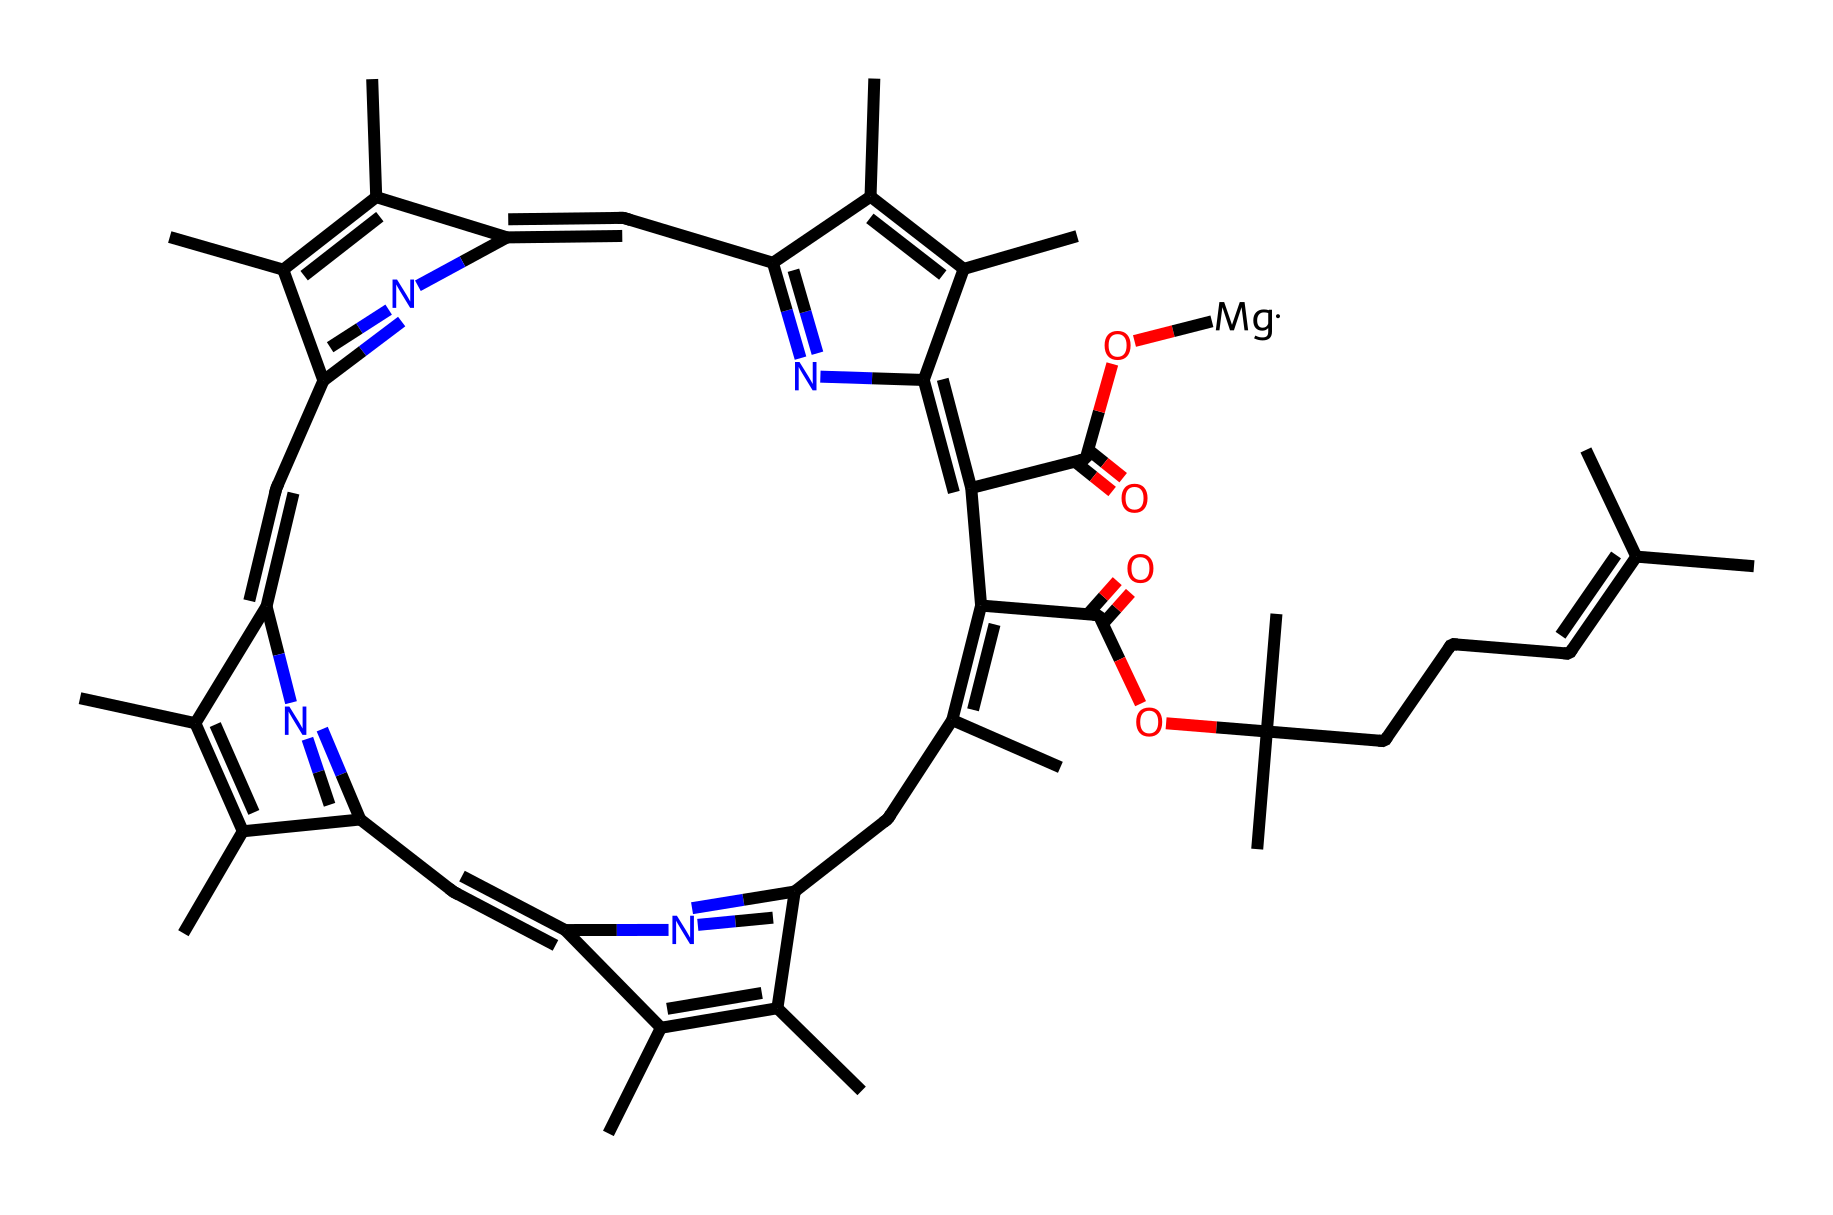What is the central metal atom in the chlorophyll structure? The SMILES representation indicates the presence of a magnesium atom, which is typically located at the center of the chlorophyll molecule, coordinating with the surrounding nitrogen and carbon atoms in the structure.
Answer: magnesium How many nitrogen atoms are present in chlorophyll? In the given SMILES representation, by counting the occurrences of 'N', we find that there are 4 nitrogen atoms present in the chlorophyll structure.
Answer: 4 What functional group is indicated by "C(=O)" in the chlorophyll structure? The "C(=O)" notation represents a carbonyl group, which is characteristic of both ketones and aldehydes. In the context of chlorophyll, these groups are part of the carboxylic acids present in the molecule.
Answer: carbonyl What type of compound is chlorophyll classified as? Chlorophyll is classified as a coordination compound due to its central metal atom, magnesium, bonded to multiple ligands which include nitrogen and carbon atoms in its structure.
Answer: coordination compound How many carbon atoms can be identified in the chlorophyll structure? By analyzing the SMILES representation, we can count all the 'C' occurrences and find there are 22 carbon atoms in the chlorophyll structure.
Answer: 22 What distinguishes chlorophyll’s coordination compound nature? Chlorophyll's coordination nature is indicated by the presence of a central metal (magnesium) surrounded by ligands (nitrogen and carbon), which helps in absorbing light needed for photosynthesis, a hallmark of coordination compounds.
Answer: central metal and ligands 